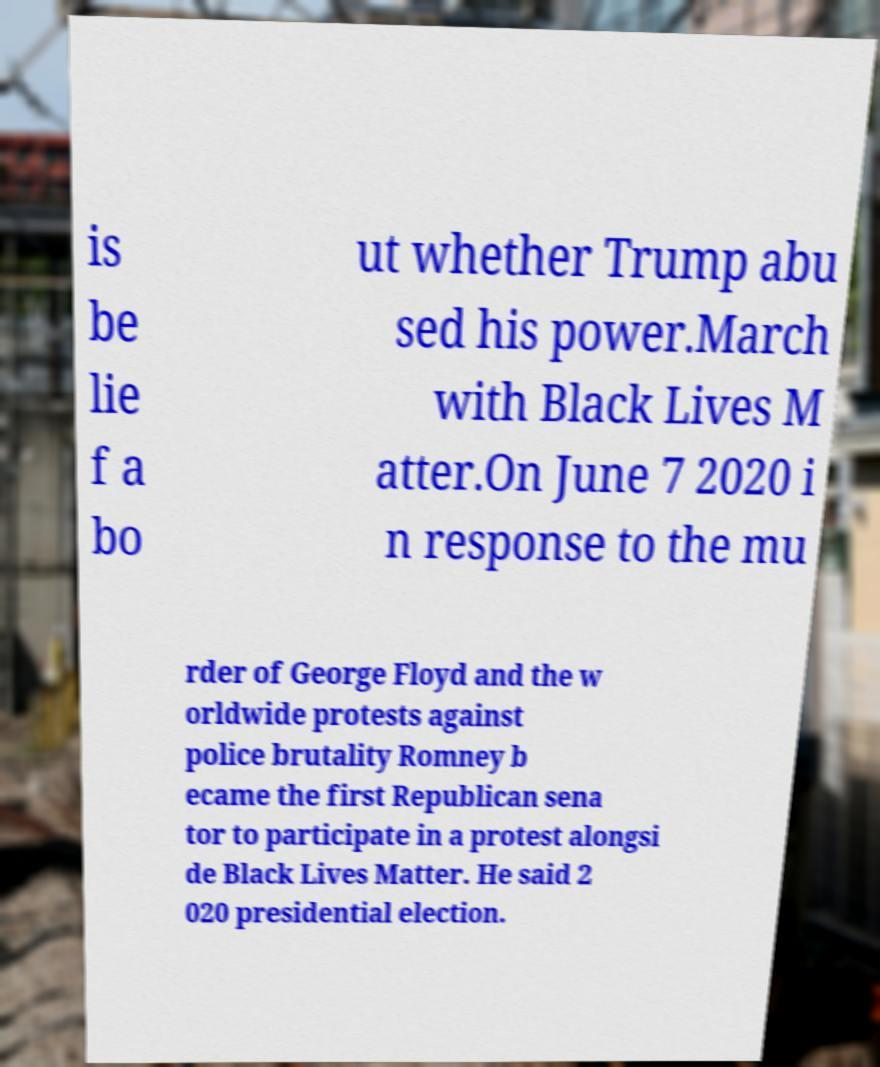Can you read and provide the text displayed in the image?This photo seems to have some interesting text. Can you extract and type it out for me? is be lie f a bo ut whether Trump abu sed his power.March with Black Lives M atter.On June 7 2020 i n response to the mu rder of George Floyd and the w orldwide protests against police brutality Romney b ecame the first Republican sena tor to participate in a protest alongsi de Black Lives Matter. He said 2 020 presidential election. 